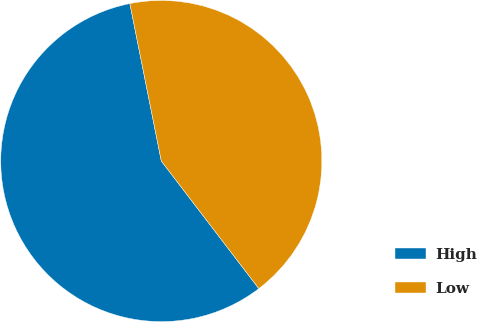Convert chart to OTSL. <chart><loc_0><loc_0><loc_500><loc_500><pie_chart><fcel>High<fcel>Low<nl><fcel>57.25%<fcel>42.75%<nl></chart> 